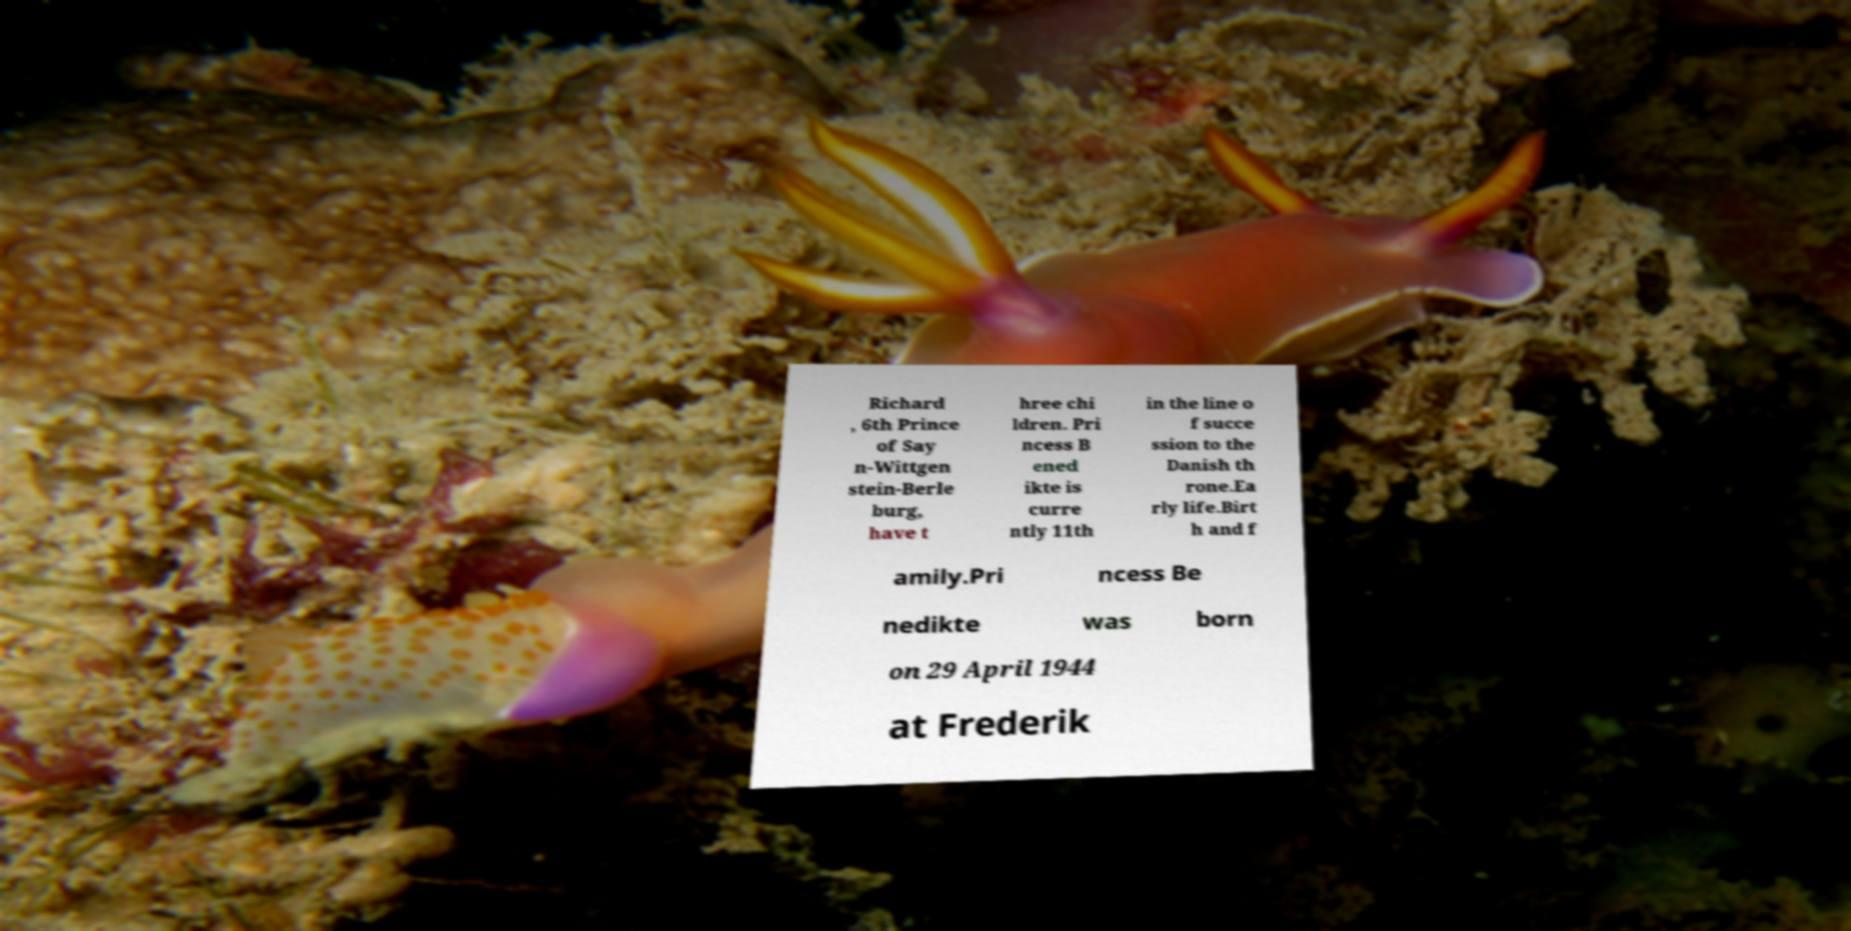For documentation purposes, I need the text within this image transcribed. Could you provide that? Richard , 6th Prince of Say n-Wittgen stein-Berle burg, have t hree chi ldren. Pri ncess B ened ikte is curre ntly 11th in the line o f succe ssion to the Danish th rone.Ea rly life.Birt h and f amily.Pri ncess Be nedikte was born on 29 April 1944 at Frederik 